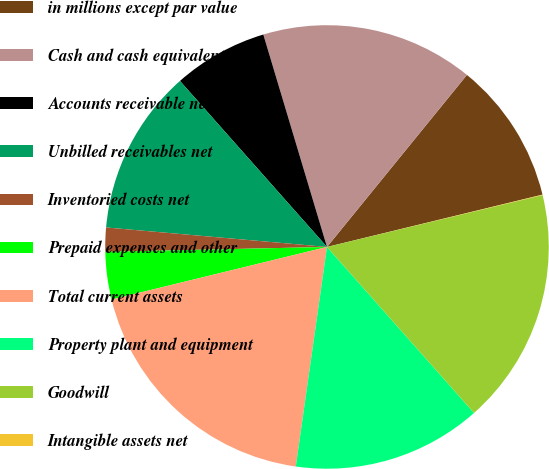Convert chart to OTSL. <chart><loc_0><loc_0><loc_500><loc_500><pie_chart><fcel>in millions except par value<fcel>Cash and cash equivalents<fcel>Accounts receivable net<fcel>Unbilled receivables net<fcel>Inventoried costs net<fcel>Prepaid expenses and other<fcel>Total current assets<fcel>Property plant and equipment<fcel>Goodwill<fcel>Intangible assets net<nl><fcel>10.34%<fcel>15.5%<fcel>6.9%<fcel>12.06%<fcel>1.75%<fcel>3.46%<fcel>18.94%<fcel>13.78%<fcel>17.22%<fcel>0.03%<nl></chart> 